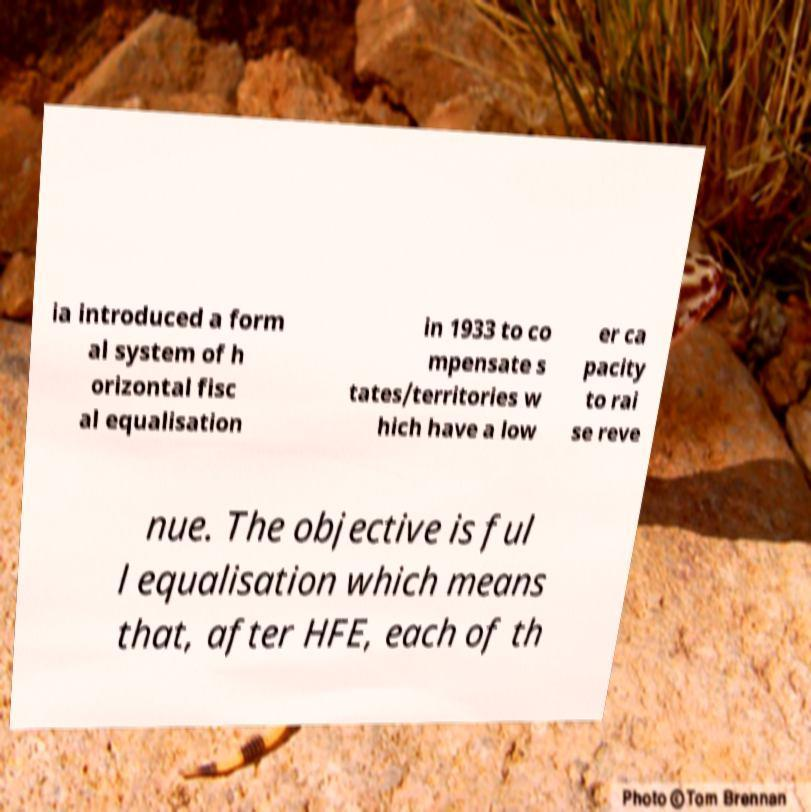Could you extract and type out the text from this image? ia introduced a form al system of h orizontal fisc al equalisation in 1933 to co mpensate s tates/territories w hich have a low er ca pacity to rai se reve nue. The objective is ful l equalisation which means that, after HFE, each of th 